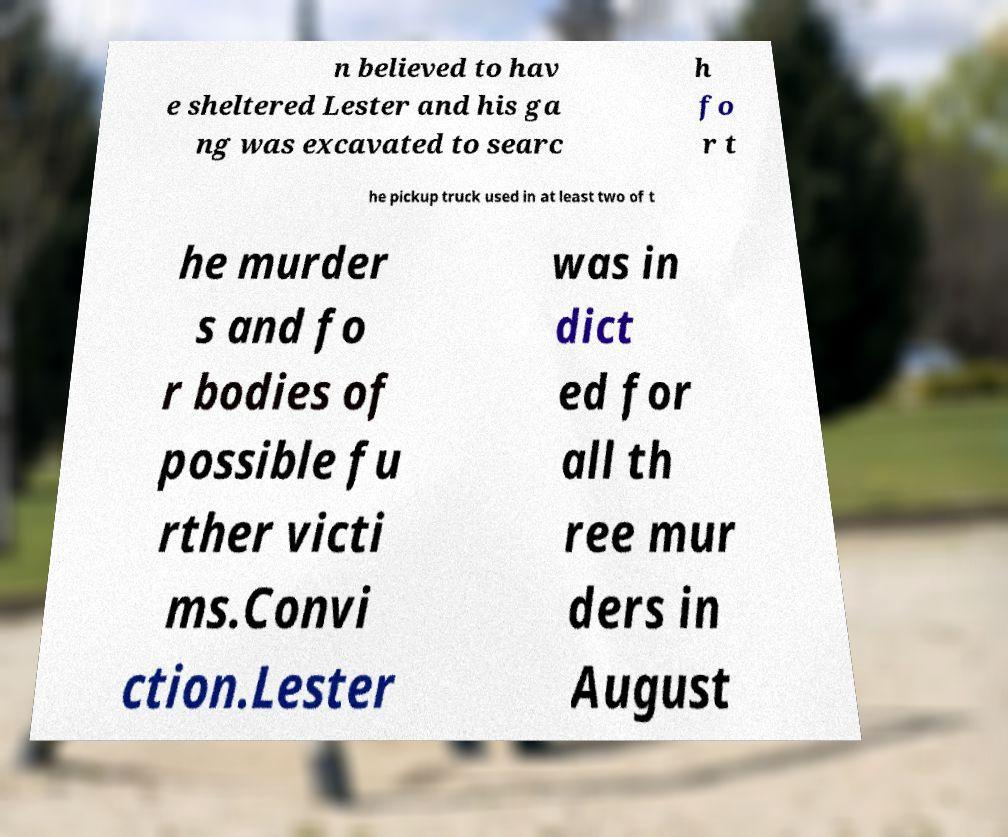For documentation purposes, I need the text within this image transcribed. Could you provide that? n believed to hav e sheltered Lester and his ga ng was excavated to searc h fo r t he pickup truck used in at least two of t he murder s and fo r bodies of possible fu rther victi ms.Convi ction.Lester was in dict ed for all th ree mur ders in August 